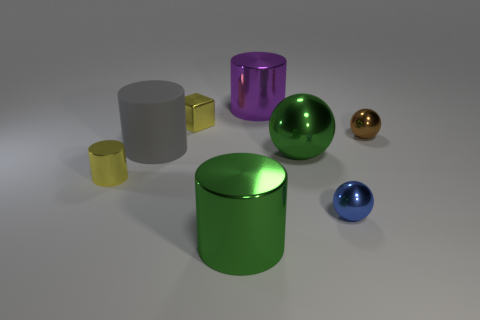What number of things are yellow metallic cubes or big shiny cylinders?
Ensure brevity in your answer.  3. Is the size of the metallic cylinder to the right of the green cylinder the same as the metal block?
Provide a succinct answer. No. What is the size of the metallic object that is behind the large gray rubber thing and in front of the tiny shiny block?
Make the answer very short. Small. What number of other objects are there of the same shape as the rubber object?
Make the answer very short. 3. What number of other objects are the same material as the large purple thing?
Provide a succinct answer. 6. There is a blue metallic object that is the same shape as the brown metal thing; what size is it?
Provide a succinct answer. Small. Do the small metallic cylinder and the small block have the same color?
Provide a succinct answer. Yes. There is a tiny metal thing that is both in front of the gray cylinder and right of the purple cylinder; what color is it?
Offer a terse response. Blue. What number of things are cylinders in front of the small brown sphere or tiny metallic cylinders?
Offer a very short reply. 3. There is a big shiny object that is the same shape as the small brown metallic thing; what is its color?
Offer a terse response. Green. 